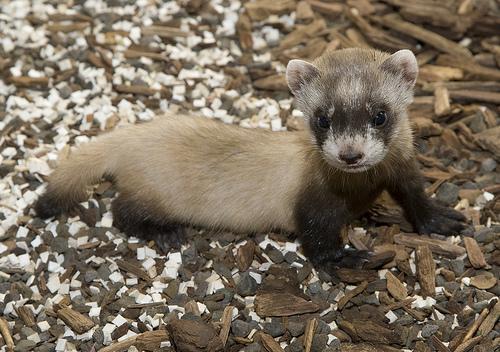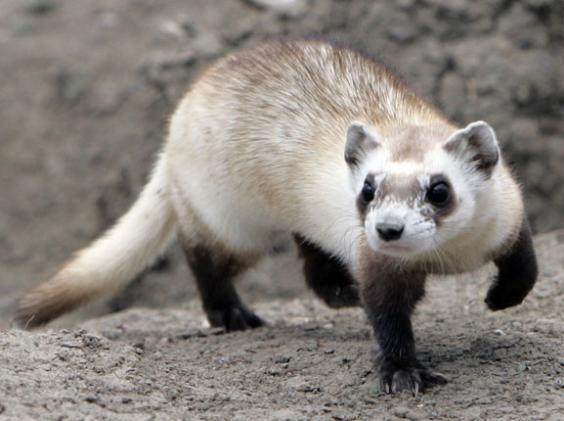The first image is the image on the left, the second image is the image on the right. Assess this claim about the two images: "The animal in the image on the right is holding one paw off the ground.". Correct or not? Answer yes or no. Yes. The first image is the image on the left, the second image is the image on the right. Evaluate the accuracy of this statement regarding the images: "A total of two ferrets are shown, each of them fully above ground.". Is it true? Answer yes or no. Yes. 